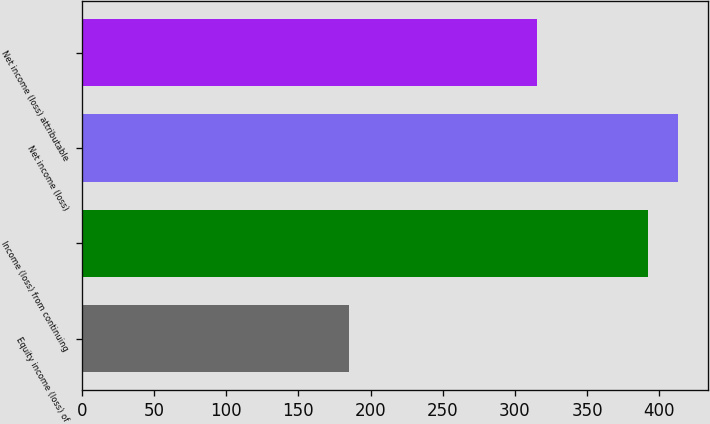<chart> <loc_0><loc_0><loc_500><loc_500><bar_chart><fcel>Equity income (loss) of<fcel>Income (loss) from continuing<fcel>Net income (loss)<fcel>Net income (loss) attributable<nl><fcel>185<fcel>392<fcel>412.7<fcel>315<nl></chart> 